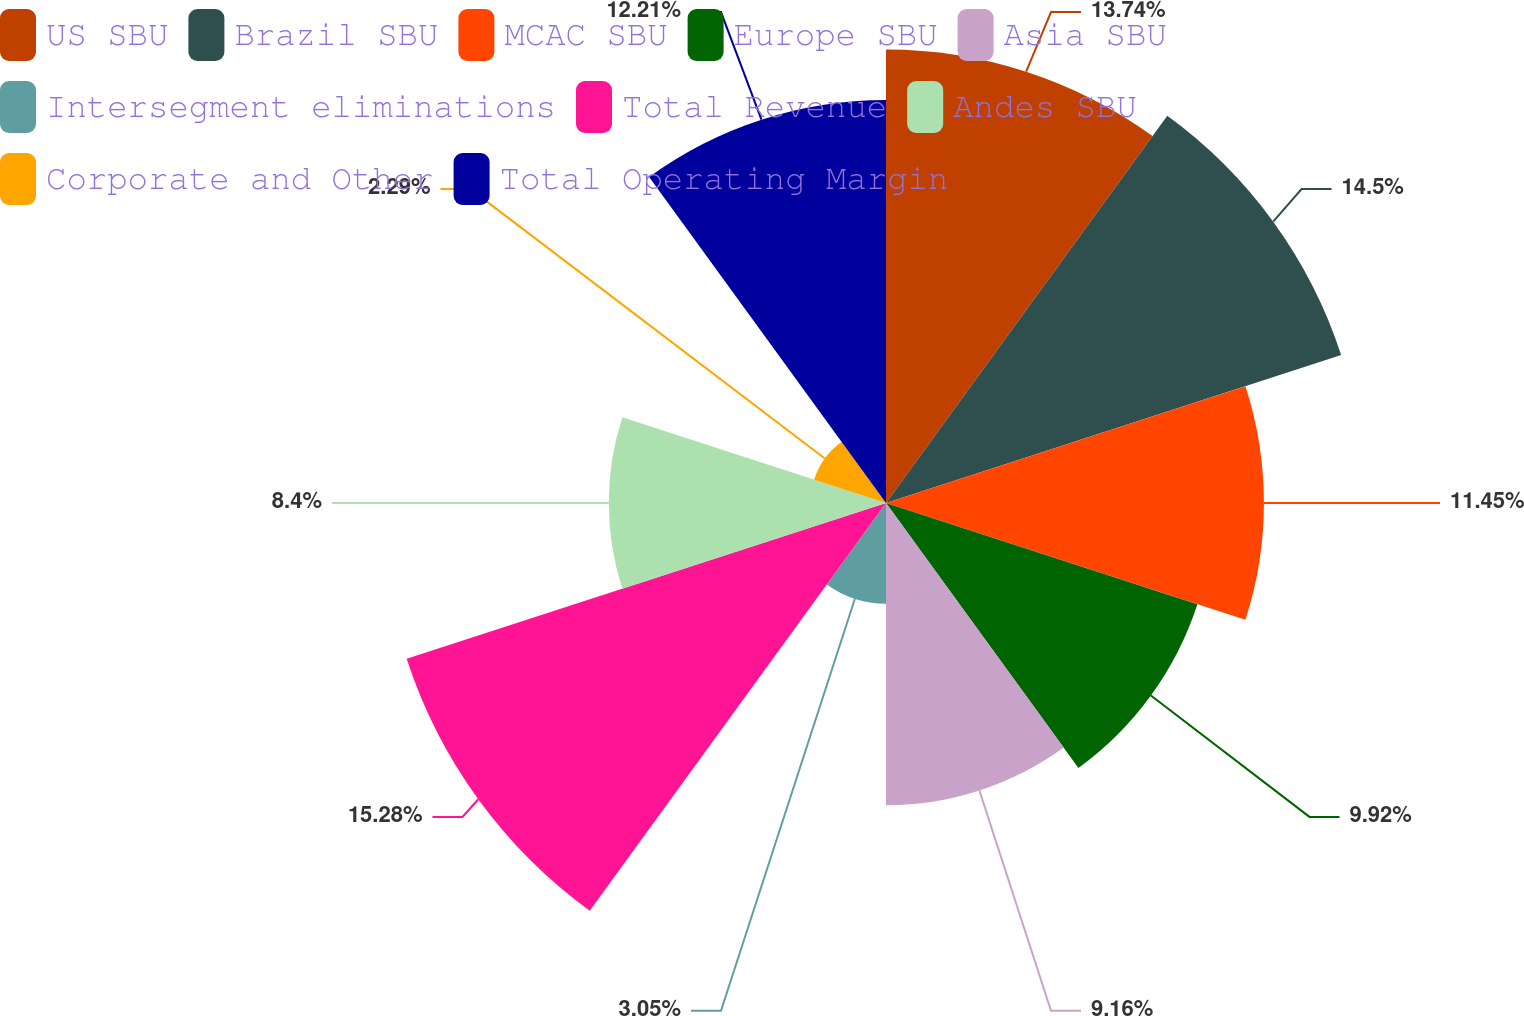Convert chart. <chart><loc_0><loc_0><loc_500><loc_500><pie_chart><fcel>US SBU<fcel>Brazil SBU<fcel>MCAC SBU<fcel>Europe SBU<fcel>Asia SBU<fcel>Intersegment eliminations<fcel>Total Revenue<fcel>Andes SBU<fcel>Corporate and Other<fcel>Total Operating Margin<nl><fcel>13.74%<fcel>14.5%<fcel>11.45%<fcel>9.92%<fcel>9.16%<fcel>3.05%<fcel>15.27%<fcel>8.4%<fcel>2.29%<fcel>12.21%<nl></chart> 